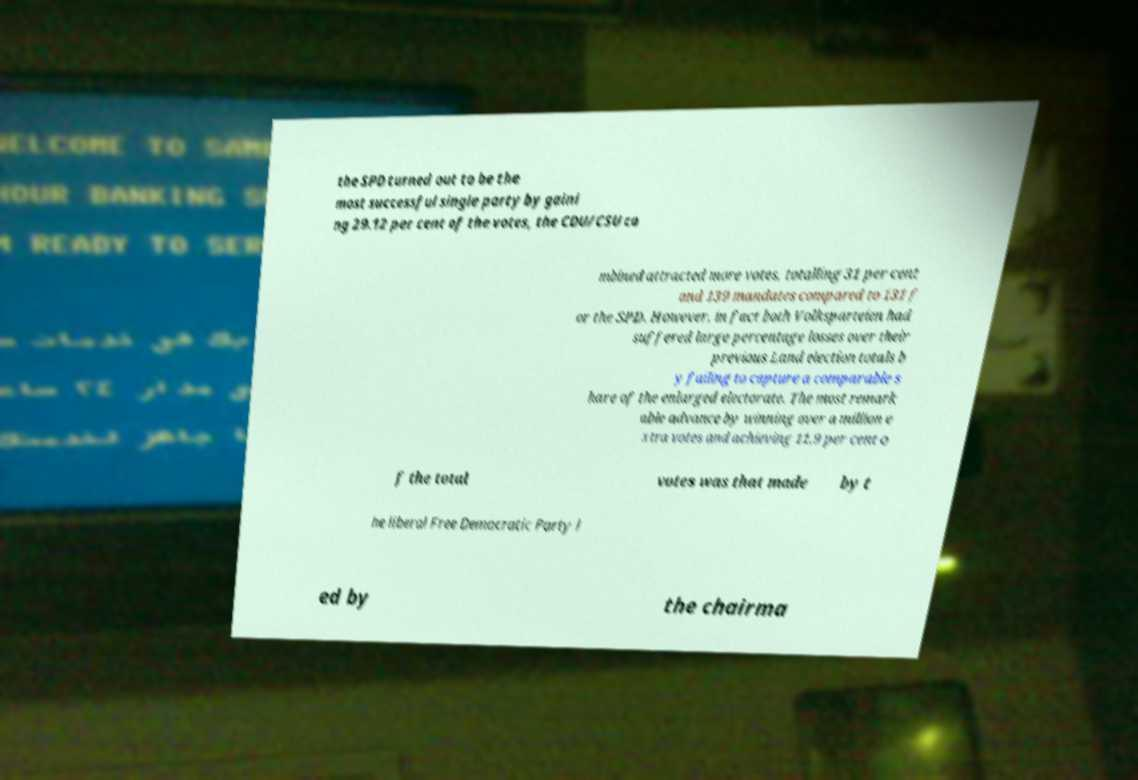For documentation purposes, I need the text within this image transcribed. Could you provide that? the SPD turned out to be the most successful single party by gaini ng 29.12 per cent of the votes, the CDU/CSU co mbined attracted more votes, totalling 31 per cent and 139 mandates compared to 131 f or the SPD. However, in fact both Volksparteien had suffered large percentage losses over their previous Land election totals b y failing to capture a comparable s hare of the enlarged electorate. The most remark able advance by winning over a million e xtra votes and achieving 11.9 per cent o f the total votes was that made by t he liberal Free Democratic Party l ed by the chairma 